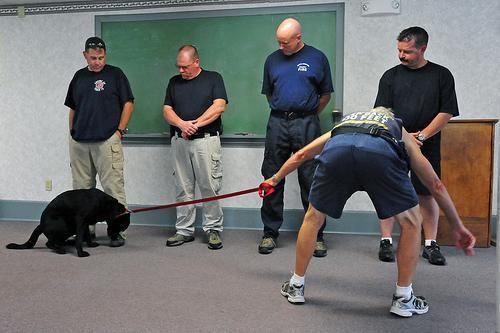How many people are there?
Give a very brief answer. 5. 